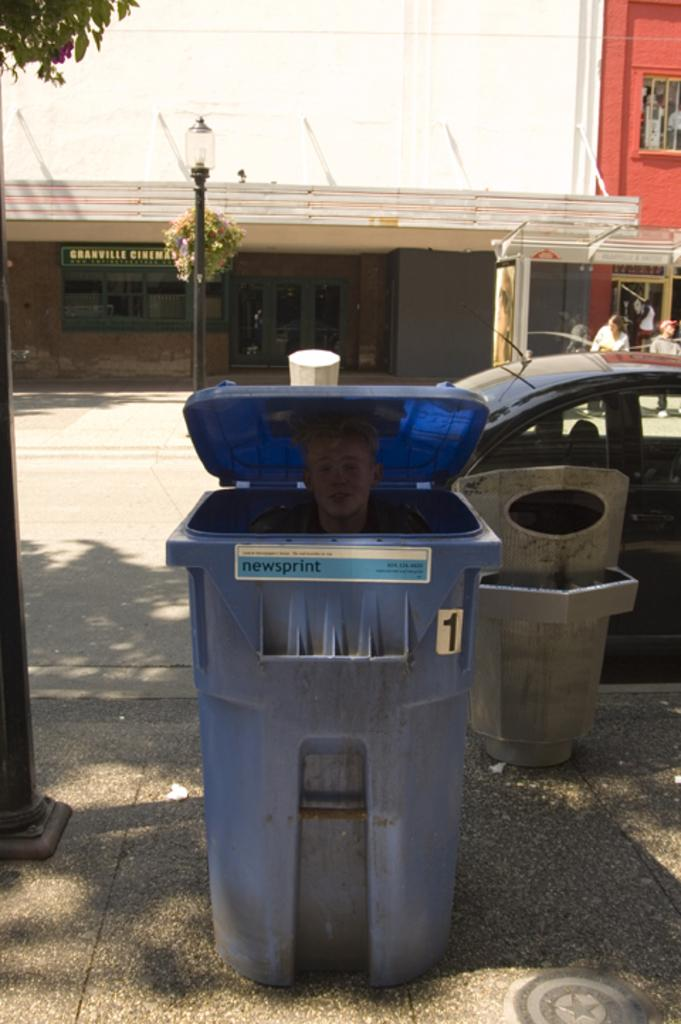<image>
Share a concise interpretation of the image provided. Blue garbage can with a man inside and a label that says "newsprint". 